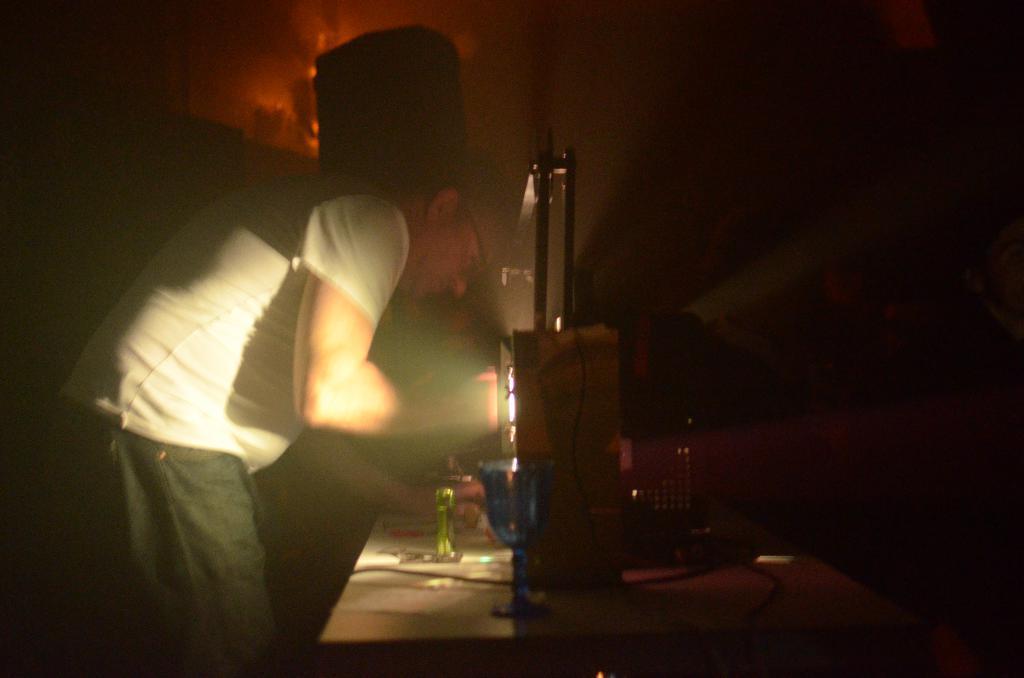Can you describe this image briefly? In this image I can see a man is standing on the left side and I can see he is wearing white colour t-shirt, jeans and a specs. On the right side of this image I can see a table and on it I can see a glass, a light and few other stuffs. I can also see this image is little bit in dark. 